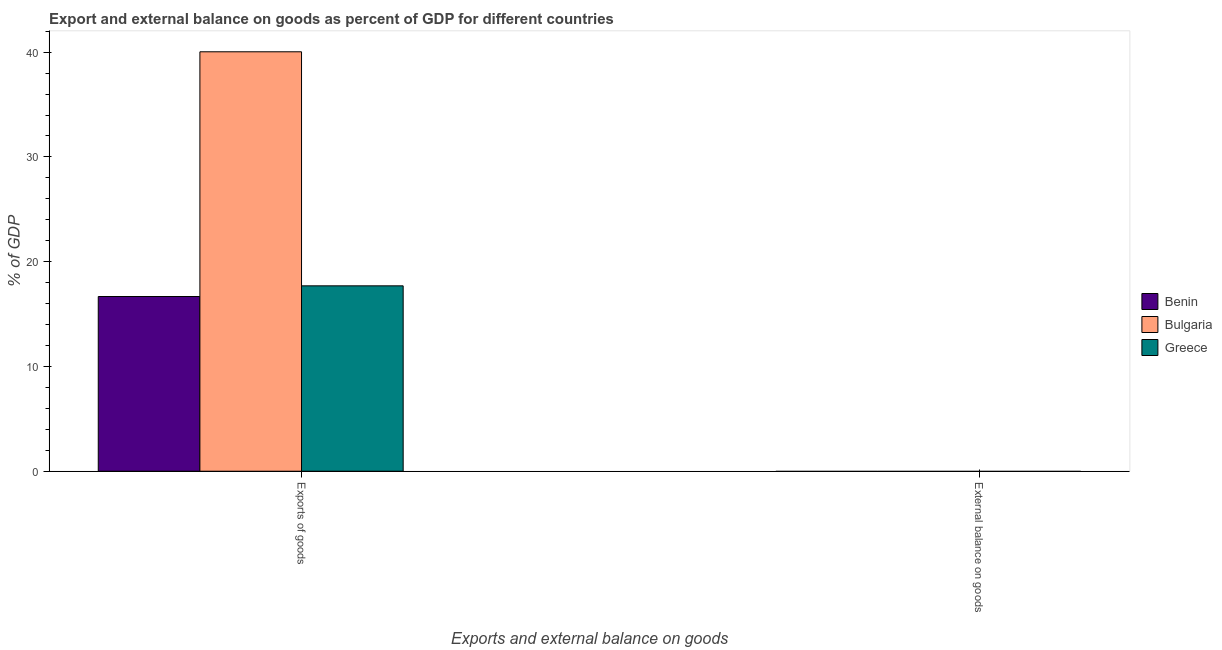Are the number of bars per tick equal to the number of legend labels?
Provide a succinct answer. No. Are the number of bars on each tick of the X-axis equal?
Provide a short and direct response. No. How many bars are there on the 1st tick from the right?
Ensure brevity in your answer.  0. What is the label of the 1st group of bars from the left?
Provide a succinct answer. Exports of goods. Across all countries, what is the maximum export of goods as percentage of gdp?
Provide a succinct answer. 40.03. Across all countries, what is the minimum export of goods as percentage of gdp?
Provide a succinct answer. 16.68. What is the total external balance on goods as percentage of gdp in the graph?
Ensure brevity in your answer.  0. What is the difference between the export of goods as percentage of gdp in Benin and that in Bulgaria?
Your answer should be compact. -23.36. What is the difference between the export of goods as percentage of gdp in Benin and the external balance on goods as percentage of gdp in Greece?
Your answer should be very brief. 16.68. In how many countries, is the export of goods as percentage of gdp greater than 6 %?
Ensure brevity in your answer.  3. What is the ratio of the export of goods as percentage of gdp in Greece to that in Bulgaria?
Offer a terse response. 0.44. In how many countries, is the external balance on goods as percentage of gdp greater than the average external balance on goods as percentage of gdp taken over all countries?
Give a very brief answer. 0. How many countries are there in the graph?
Your response must be concise. 3. Are the values on the major ticks of Y-axis written in scientific E-notation?
Make the answer very short. No. Does the graph contain any zero values?
Provide a succinct answer. Yes. Where does the legend appear in the graph?
Offer a very short reply. Center right. What is the title of the graph?
Provide a short and direct response. Export and external balance on goods as percent of GDP for different countries. Does "New Caledonia" appear as one of the legend labels in the graph?
Your answer should be very brief. No. What is the label or title of the X-axis?
Make the answer very short. Exports and external balance on goods. What is the label or title of the Y-axis?
Offer a very short reply. % of GDP. What is the % of GDP of Benin in Exports of goods?
Your answer should be compact. 16.68. What is the % of GDP of Bulgaria in Exports of goods?
Ensure brevity in your answer.  40.03. What is the % of GDP of Greece in Exports of goods?
Give a very brief answer. 17.69. What is the % of GDP in Benin in External balance on goods?
Ensure brevity in your answer.  0. What is the % of GDP in Greece in External balance on goods?
Keep it short and to the point. 0. Across all Exports and external balance on goods, what is the maximum % of GDP in Benin?
Make the answer very short. 16.68. Across all Exports and external balance on goods, what is the maximum % of GDP in Bulgaria?
Make the answer very short. 40.03. Across all Exports and external balance on goods, what is the maximum % of GDP in Greece?
Provide a short and direct response. 17.69. What is the total % of GDP of Benin in the graph?
Make the answer very short. 16.68. What is the total % of GDP in Bulgaria in the graph?
Your answer should be compact. 40.03. What is the total % of GDP of Greece in the graph?
Provide a short and direct response. 17.69. What is the average % of GDP of Benin per Exports and external balance on goods?
Offer a terse response. 8.34. What is the average % of GDP in Bulgaria per Exports and external balance on goods?
Make the answer very short. 20.02. What is the average % of GDP of Greece per Exports and external balance on goods?
Offer a very short reply. 8.85. What is the difference between the % of GDP of Benin and % of GDP of Bulgaria in Exports of goods?
Keep it short and to the point. -23.36. What is the difference between the % of GDP in Benin and % of GDP in Greece in Exports of goods?
Provide a succinct answer. -1.02. What is the difference between the % of GDP of Bulgaria and % of GDP of Greece in Exports of goods?
Your answer should be very brief. 22.34. What is the difference between the highest and the lowest % of GDP of Benin?
Provide a succinct answer. 16.68. What is the difference between the highest and the lowest % of GDP of Bulgaria?
Offer a very short reply. 40.03. What is the difference between the highest and the lowest % of GDP in Greece?
Offer a very short reply. 17.69. 